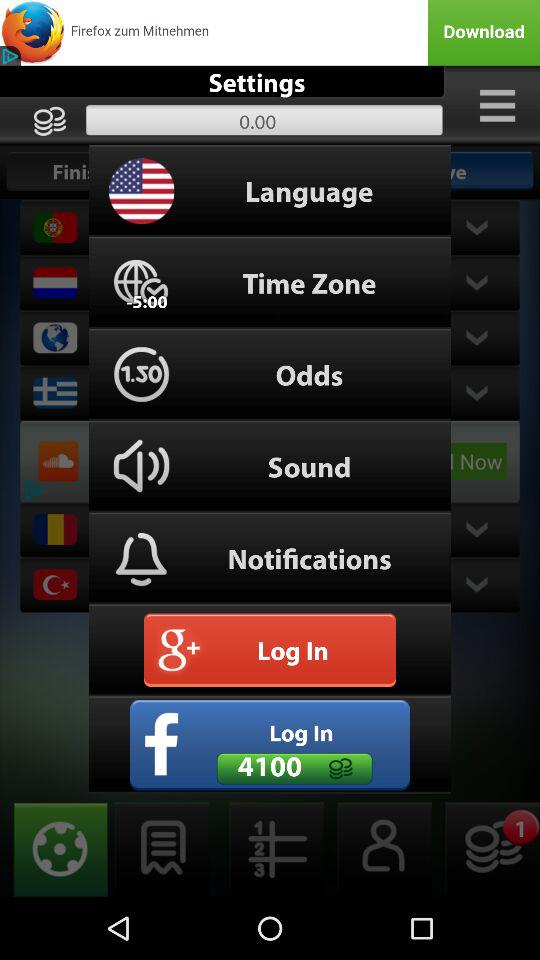How many coins will the user get for logging in through "Facebook"? The user will get 4100 coins for logging in through "Facebook". 